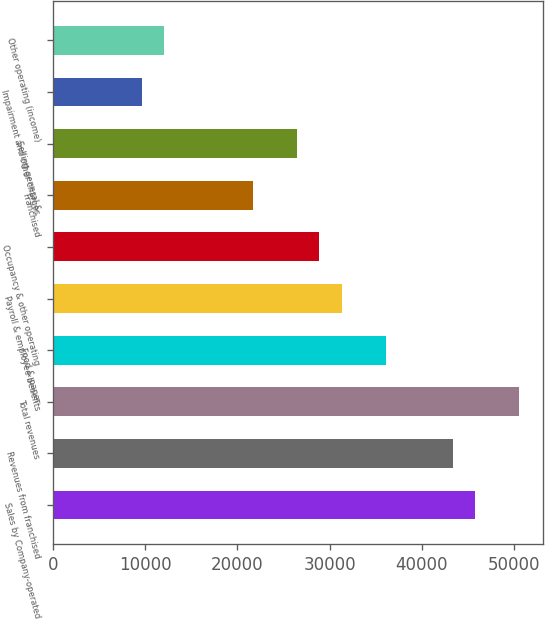<chart> <loc_0><loc_0><loc_500><loc_500><bar_chart><fcel>Sales by Company-operated<fcel>Revenues from franchised<fcel>Total revenues<fcel>Food & paper<fcel>Payroll & employee benefits<fcel>Occupancy & other operating<fcel>Franchised<fcel>Selling general &<fcel>Impairment and other charges<fcel>Other operating (income)<nl><fcel>45739.6<fcel>43332.4<fcel>50554.1<fcel>36110.7<fcel>31296.2<fcel>28889<fcel>21667.3<fcel>26481.8<fcel>9631.18<fcel>12038.4<nl></chart> 